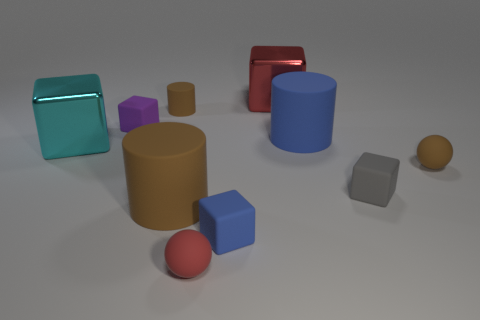How many other objects are the same size as the brown matte ball?
Give a very brief answer. 5. What material is the tiny brown thing that is in front of the large cyan metallic object?
Your answer should be very brief. Rubber. Is the large cyan metal thing the same shape as the gray thing?
Keep it short and to the point. Yes. How many other things are there of the same shape as the big cyan thing?
Provide a succinct answer. 4. There is a small rubber thing that is behind the small purple matte cube; what is its color?
Your answer should be compact. Brown. Is the size of the cyan shiny thing the same as the gray block?
Your response must be concise. No. What is the small brown object that is to the right of the brown rubber thing that is behind the blue matte cylinder made of?
Give a very brief answer. Rubber. How many tiny spheres are the same color as the tiny rubber cylinder?
Give a very brief answer. 1. Is the number of rubber objects in front of the big brown cylinder less than the number of large yellow rubber blocks?
Provide a succinct answer. No. There is a cylinder that is in front of the tiny brown matte object on the right side of the tiny red rubber object; what color is it?
Keep it short and to the point. Brown. 